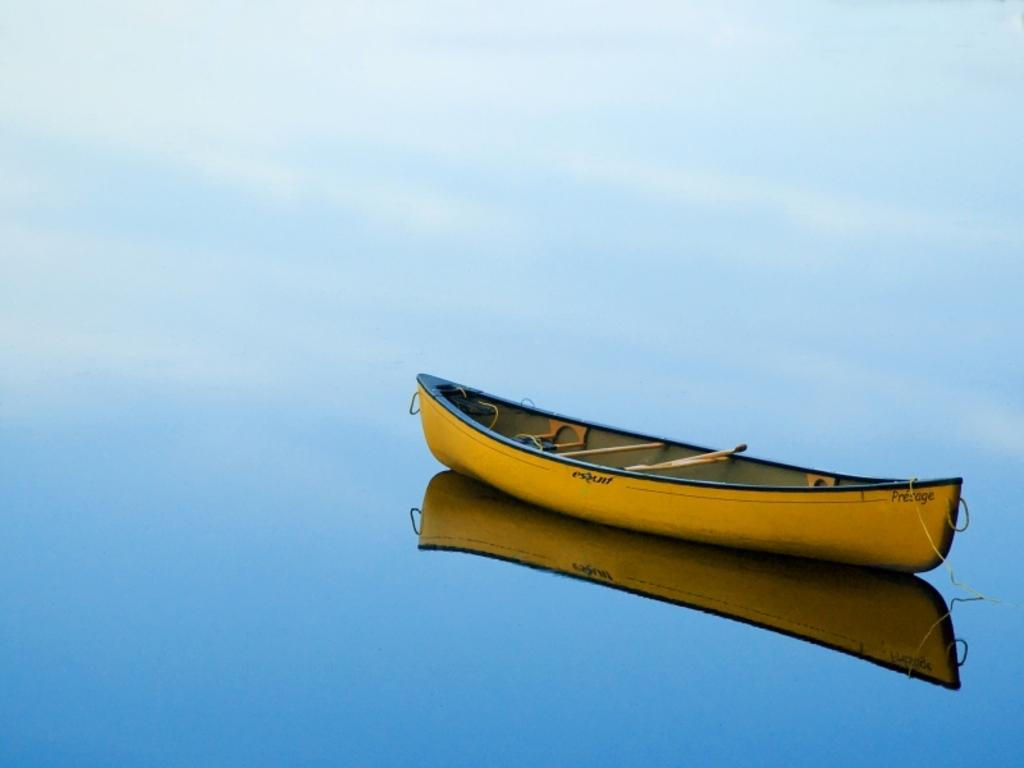What is the main subject of the image? The main subject of the image is a boat. Where is the boat located? The boat is in a lake. What color is the boat? The boat is yellow in color. What type of camp can be seen near the boat in the image? There is no camp visible in the image; it only features a boat in a lake. 